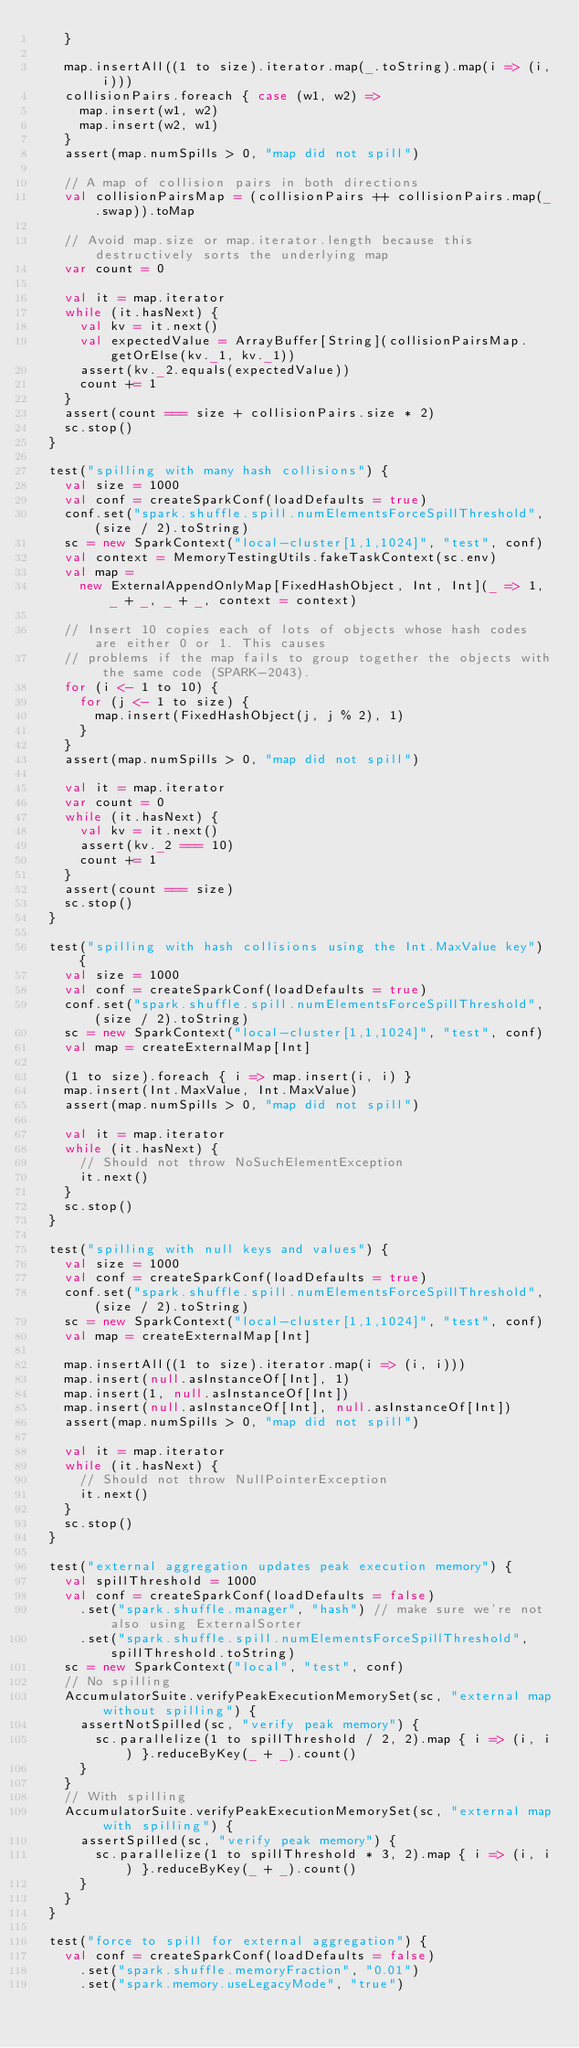<code> <loc_0><loc_0><loc_500><loc_500><_Scala_>    }

    map.insertAll((1 to size).iterator.map(_.toString).map(i => (i, i)))
    collisionPairs.foreach { case (w1, w2) =>
      map.insert(w1, w2)
      map.insert(w2, w1)
    }
    assert(map.numSpills > 0, "map did not spill")

    // A map of collision pairs in both directions
    val collisionPairsMap = (collisionPairs ++ collisionPairs.map(_.swap)).toMap

    // Avoid map.size or map.iterator.length because this destructively sorts the underlying map
    var count = 0

    val it = map.iterator
    while (it.hasNext) {
      val kv = it.next()
      val expectedValue = ArrayBuffer[String](collisionPairsMap.getOrElse(kv._1, kv._1))
      assert(kv._2.equals(expectedValue))
      count += 1
    }
    assert(count === size + collisionPairs.size * 2)
    sc.stop()
  }

  test("spilling with many hash collisions") {
    val size = 1000
    val conf = createSparkConf(loadDefaults = true)
    conf.set("spark.shuffle.spill.numElementsForceSpillThreshold", (size / 2).toString)
    sc = new SparkContext("local-cluster[1,1,1024]", "test", conf)
    val context = MemoryTestingUtils.fakeTaskContext(sc.env)
    val map =
      new ExternalAppendOnlyMap[FixedHashObject, Int, Int](_ => 1, _ + _, _ + _, context = context)

    // Insert 10 copies each of lots of objects whose hash codes are either 0 or 1. This causes
    // problems if the map fails to group together the objects with the same code (SPARK-2043).
    for (i <- 1 to 10) {
      for (j <- 1 to size) {
        map.insert(FixedHashObject(j, j % 2), 1)
      }
    }
    assert(map.numSpills > 0, "map did not spill")

    val it = map.iterator
    var count = 0
    while (it.hasNext) {
      val kv = it.next()
      assert(kv._2 === 10)
      count += 1
    }
    assert(count === size)
    sc.stop()
  }

  test("spilling with hash collisions using the Int.MaxValue key") {
    val size = 1000
    val conf = createSparkConf(loadDefaults = true)
    conf.set("spark.shuffle.spill.numElementsForceSpillThreshold", (size / 2).toString)
    sc = new SparkContext("local-cluster[1,1,1024]", "test", conf)
    val map = createExternalMap[Int]

    (1 to size).foreach { i => map.insert(i, i) }
    map.insert(Int.MaxValue, Int.MaxValue)
    assert(map.numSpills > 0, "map did not spill")

    val it = map.iterator
    while (it.hasNext) {
      // Should not throw NoSuchElementException
      it.next()
    }
    sc.stop()
  }

  test("spilling with null keys and values") {
    val size = 1000
    val conf = createSparkConf(loadDefaults = true)
    conf.set("spark.shuffle.spill.numElementsForceSpillThreshold", (size / 2).toString)
    sc = new SparkContext("local-cluster[1,1,1024]", "test", conf)
    val map = createExternalMap[Int]

    map.insertAll((1 to size).iterator.map(i => (i, i)))
    map.insert(null.asInstanceOf[Int], 1)
    map.insert(1, null.asInstanceOf[Int])
    map.insert(null.asInstanceOf[Int], null.asInstanceOf[Int])
    assert(map.numSpills > 0, "map did not spill")

    val it = map.iterator
    while (it.hasNext) {
      // Should not throw NullPointerException
      it.next()
    }
    sc.stop()
  }

  test("external aggregation updates peak execution memory") {
    val spillThreshold = 1000
    val conf = createSparkConf(loadDefaults = false)
      .set("spark.shuffle.manager", "hash") // make sure we're not also using ExternalSorter
      .set("spark.shuffle.spill.numElementsForceSpillThreshold", spillThreshold.toString)
    sc = new SparkContext("local", "test", conf)
    // No spilling
    AccumulatorSuite.verifyPeakExecutionMemorySet(sc, "external map without spilling") {
      assertNotSpilled(sc, "verify peak memory") {
        sc.parallelize(1 to spillThreshold / 2, 2).map { i => (i, i) }.reduceByKey(_ + _).count()
      }
    }
    // With spilling
    AccumulatorSuite.verifyPeakExecutionMemorySet(sc, "external map with spilling") {
      assertSpilled(sc, "verify peak memory") {
        sc.parallelize(1 to spillThreshold * 3, 2).map { i => (i, i) }.reduceByKey(_ + _).count()
      }
    }
  }

  test("force to spill for external aggregation") {
    val conf = createSparkConf(loadDefaults = false)
      .set("spark.shuffle.memoryFraction", "0.01")
      .set("spark.memory.useLegacyMode", "true")</code> 